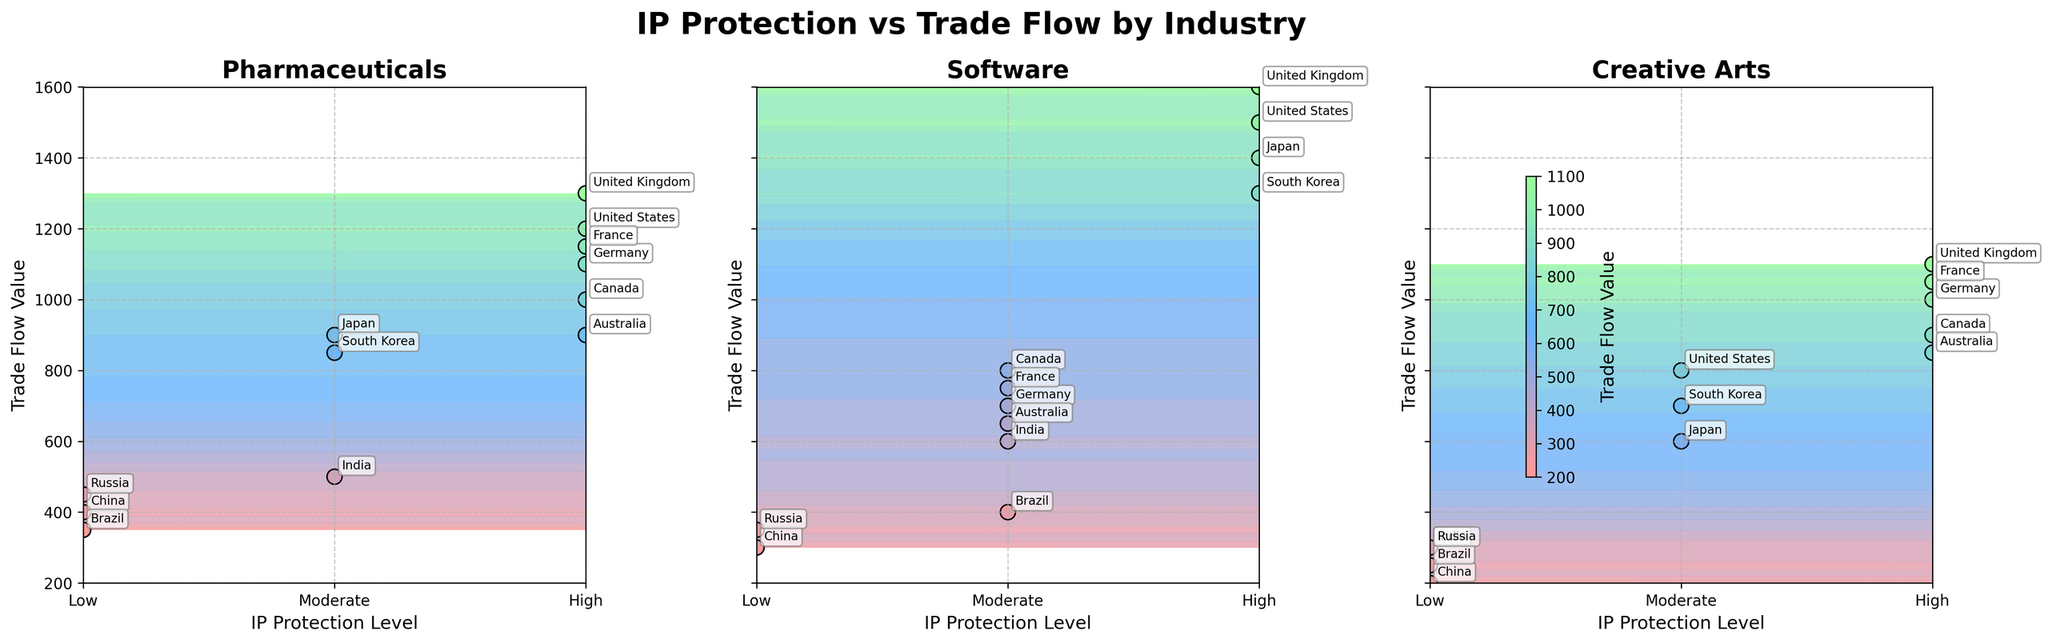What are the IP protection levels indicated by the x-axis? The x-axis shows the IP protection levels indicated by "Low," "Moderate," and "High." This can be inferred from the labels on the x-axis for each subplot.
Answer: Low, Moderate, High Which industry has the highest trade flow value among the three shown? The highest trade flow value is found in the Software industry, as indicated by the highest contour lines and scatter points in the subplot for Software.
Answer: Software What is the trade flow value for Creative Arts with low IP protection in China? In the Creative Arts subplot, the scatter point corresponding to China with low IP protection shows a trade flow value of approximately 200.
Answer: 200 Considering Pharmaceuticals, which country has a high IP protection level and the highest trade flow value? In the Pharmaceuticals subplot, the United Kingdom has both a high IP protection level and the highest trade flow value, as indicated by the position and annotation of the highest scatter point.
Answer: United Kingdom Between Japan and South Korea, which country has a higher trade flow value in the Software industry? In the Software subplot, Japan has a higher trade flow value than South Korea, as indicated by the respective positions of the scatter points and annotations.
Answer: Japan Which industry shows the lowest trade flow values with low IP protection levels? The Creative Arts industry shows the lowest trade flow values with low IP protection levels, as indicated by the lower scatter points and contour lines in the Creative Arts subplot.
Answer: Creative Arts What is the median trade flow value for Software with high IP protection levels? The trade flow values for Software with high IP protection levels are 1500, 1400, 1600, and 1300. The median value can be found by ordering these values: 1300, 1400, 1500, 1600. The median is the average of the two middle values (1400 + 1500) / 2 = 1450.
Answer: 1450 How does the trade flow value for Pharmaceuticals in Germany compare to that in France? In the Pharmaceuticals subplot, Germany has a trade flow value of approximately 1100, and France has a value of approximately 1150, showing that France has a slightly higher trade flow value.
Answer: France What is the difference in trade flow values for Creative Arts between Canada and Australia? In the Creative Arts subplot, Canada has a trade flow value of approximately 900, and Australia has a value of approximately 850. The difference is 900 - 850 = 50.
Answer: 50 